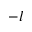Convert formula to latex. <formula><loc_0><loc_0><loc_500><loc_500>- l</formula> 